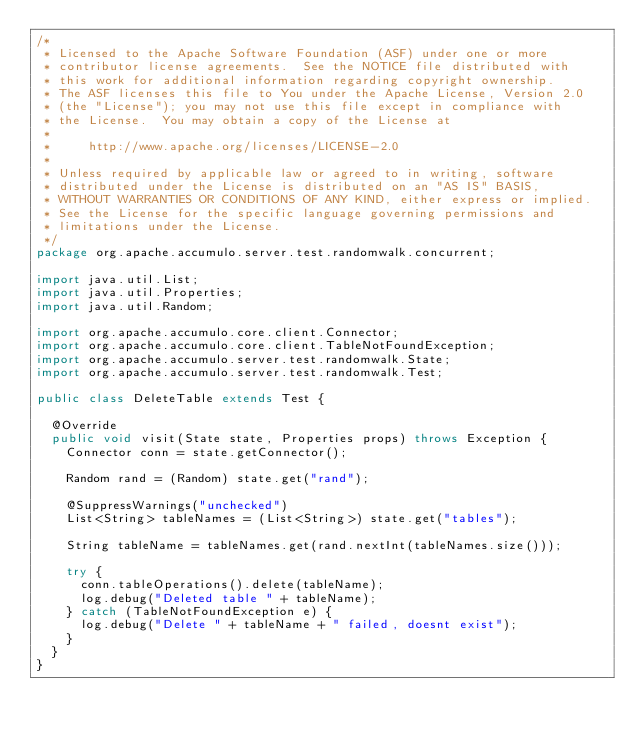<code> <loc_0><loc_0><loc_500><loc_500><_Java_>/*
 * Licensed to the Apache Software Foundation (ASF) under one or more
 * contributor license agreements.  See the NOTICE file distributed with
 * this work for additional information regarding copyright ownership.
 * The ASF licenses this file to You under the Apache License, Version 2.0
 * (the "License"); you may not use this file except in compliance with
 * the License.  You may obtain a copy of the License at
 *
 *     http://www.apache.org/licenses/LICENSE-2.0
 *
 * Unless required by applicable law or agreed to in writing, software
 * distributed under the License is distributed on an "AS IS" BASIS,
 * WITHOUT WARRANTIES OR CONDITIONS OF ANY KIND, either express or implied.
 * See the License for the specific language governing permissions and
 * limitations under the License.
 */
package org.apache.accumulo.server.test.randomwalk.concurrent;

import java.util.List;
import java.util.Properties;
import java.util.Random;

import org.apache.accumulo.core.client.Connector;
import org.apache.accumulo.core.client.TableNotFoundException;
import org.apache.accumulo.server.test.randomwalk.State;
import org.apache.accumulo.server.test.randomwalk.Test;

public class DeleteTable extends Test {
  
  @Override
  public void visit(State state, Properties props) throws Exception {
    Connector conn = state.getConnector();
    
    Random rand = (Random) state.get("rand");
    
    @SuppressWarnings("unchecked")
    List<String> tableNames = (List<String>) state.get("tables");
    
    String tableName = tableNames.get(rand.nextInt(tableNames.size()));
    
    try {
      conn.tableOperations().delete(tableName);
      log.debug("Deleted table " + tableName);
    } catch (TableNotFoundException e) {
      log.debug("Delete " + tableName + " failed, doesnt exist");
    }
  }
}
</code> 